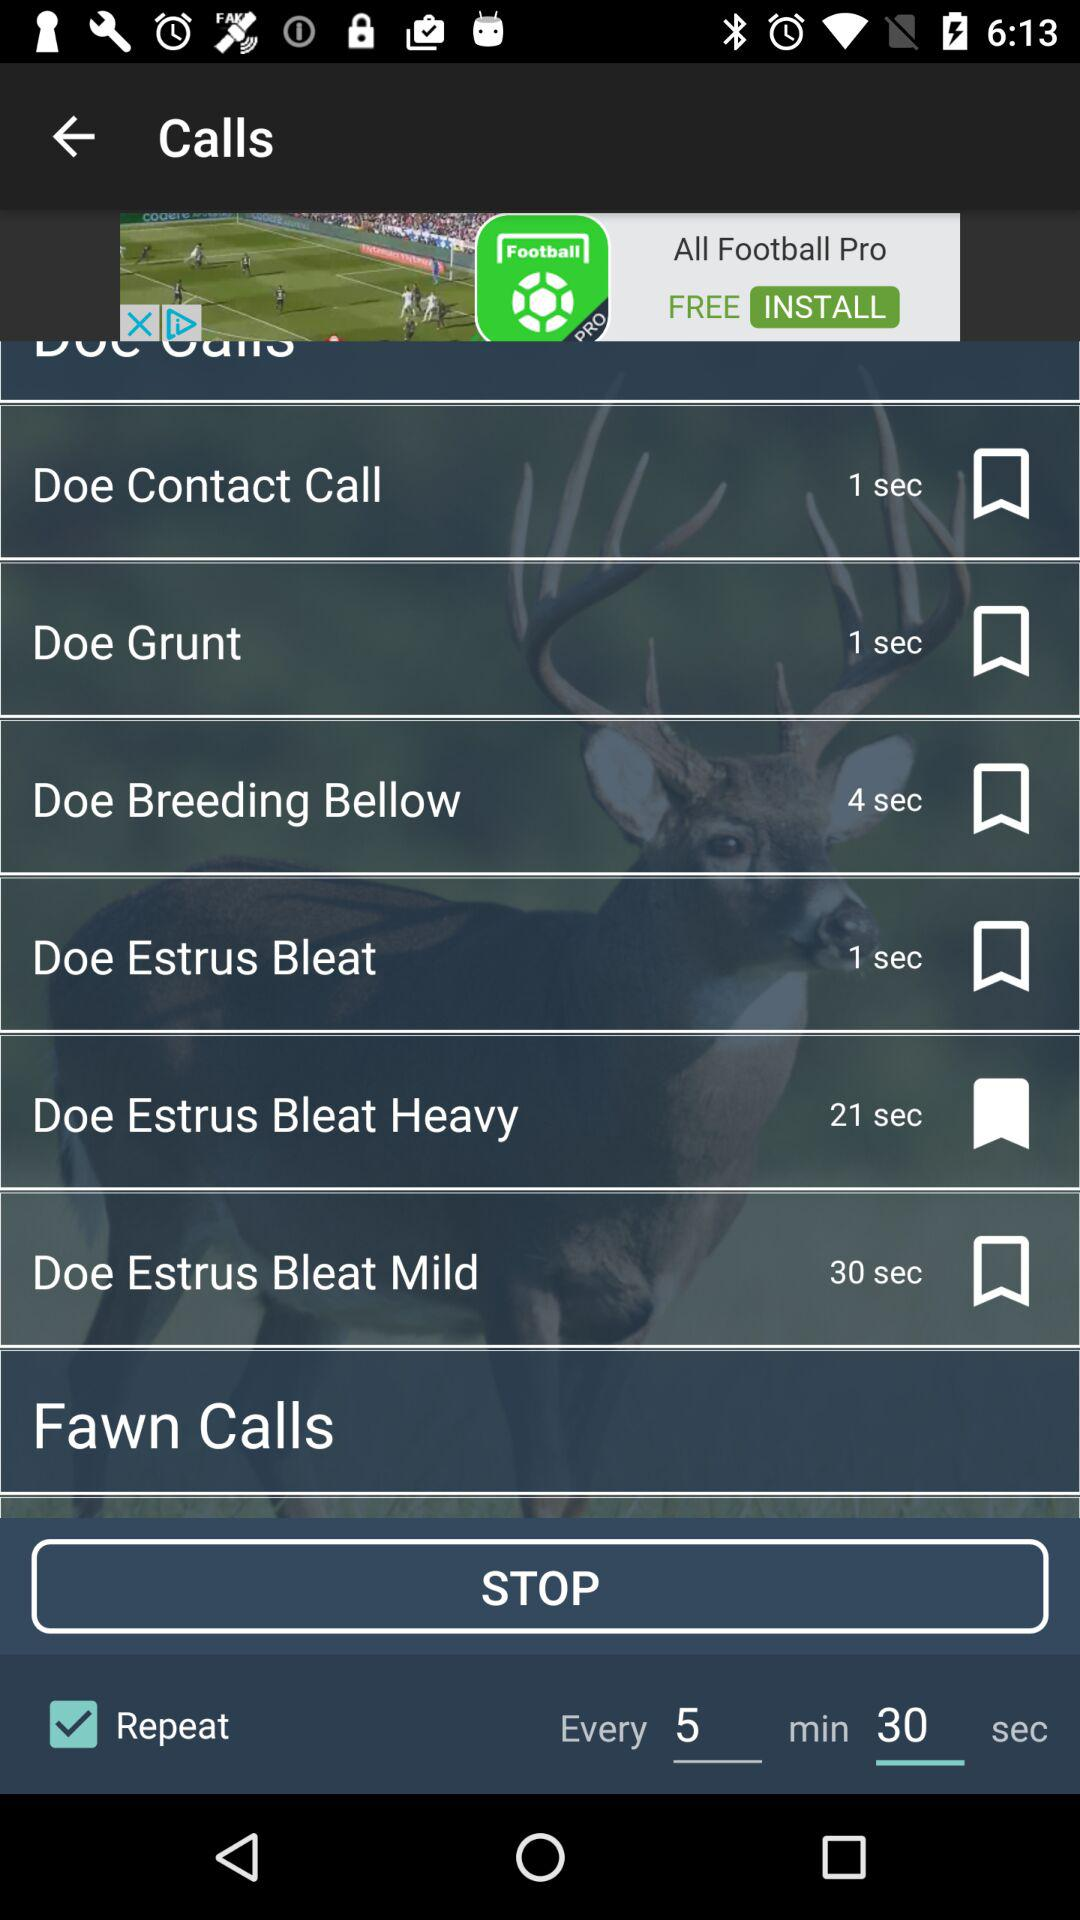What is the status of the "Repeat"? The status is "on". 